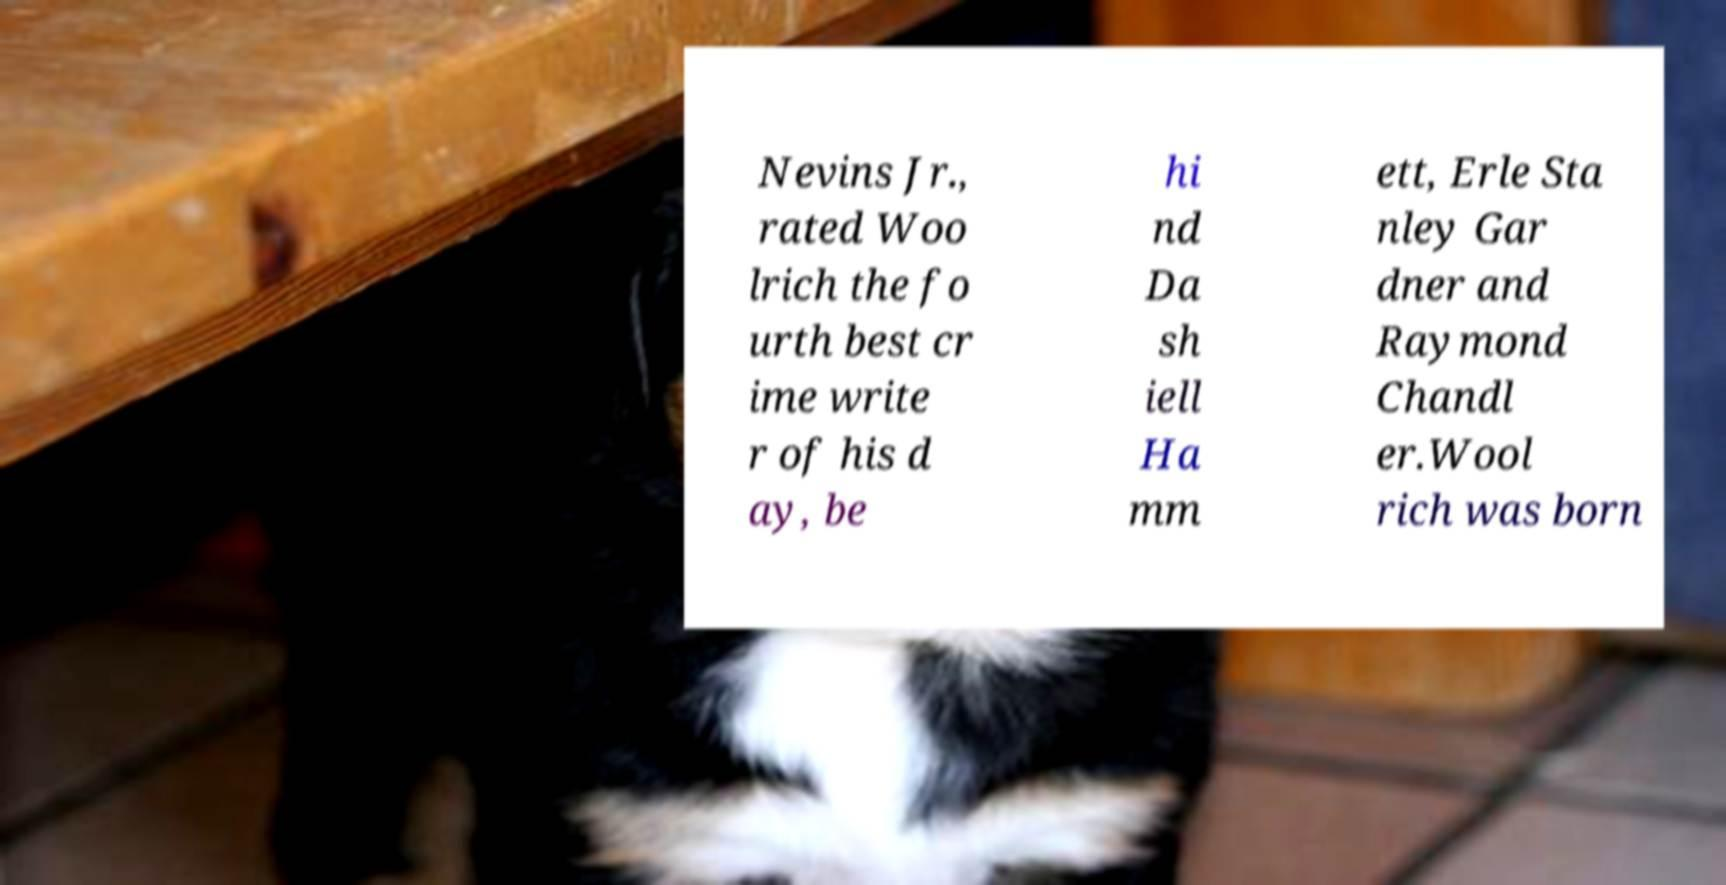Could you assist in decoding the text presented in this image and type it out clearly? Nevins Jr., rated Woo lrich the fo urth best cr ime write r of his d ay, be hi nd Da sh iell Ha mm ett, Erle Sta nley Gar dner and Raymond Chandl er.Wool rich was born 